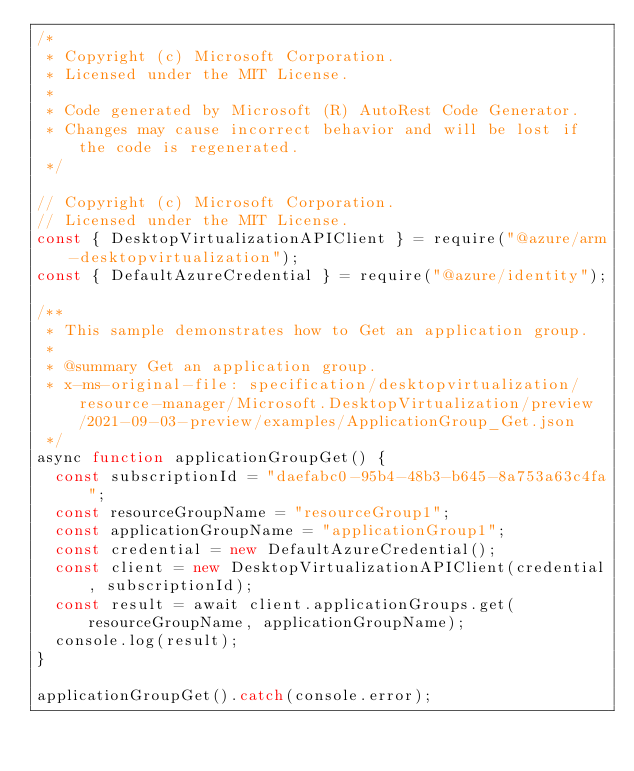Convert code to text. <code><loc_0><loc_0><loc_500><loc_500><_JavaScript_>/*
 * Copyright (c) Microsoft Corporation.
 * Licensed under the MIT License.
 *
 * Code generated by Microsoft (R) AutoRest Code Generator.
 * Changes may cause incorrect behavior and will be lost if the code is regenerated.
 */

// Copyright (c) Microsoft Corporation.
// Licensed under the MIT License.
const { DesktopVirtualizationAPIClient } = require("@azure/arm-desktopvirtualization");
const { DefaultAzureCredential } = require("@azure/identity");

/**
 * This sample demonstrates how to Get an application group.
 *
 * @summary Get an application group.
 * x-ms-original-file: specification/desktopvirtualization/resource-manager/Microsoft.DesktopVirtualization/preview/2021-09-03-preview/examples/ApplicationGroup_Get.json
 */
async function applicationGroupGet() {
  const subscriptionId = "daefabc0-95b4-48b3-b645-8a753a63c4fa";
  const resourceGroupName = "resourceGroup1";
  const applicationGroupName = "applicationGroup1";
  const credential = new DefaultAzureCredential();
  const client = new DesktopVirtualizationAPIClient(credential, subscriptionId);
  const result = await client.applicationGroups.get(resourceGroupName, applicationGroupName);
  console.log(result);
}

applicationGroupGet().catch(console.error);
</code> 